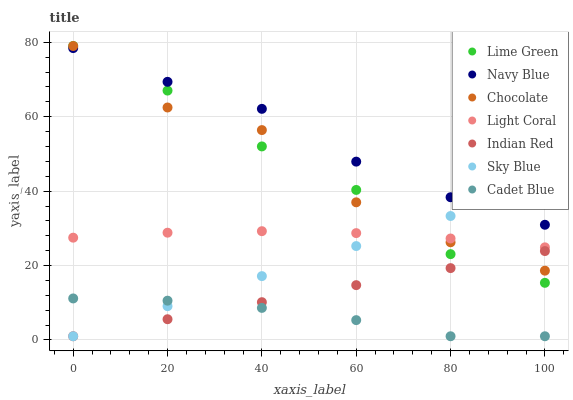Does Cadet Blue have the minimum area under the curve?
Answer yes or no. Yes. Does Navy Blue have the maximum area under the curve?
Answer yes or no. Yes. Does Chocolate have the minimum area under the curve?
Answer yes or no. No. Does Chocolate have the maximum area under the curve?
Answer yes or no. No. Is Sky Blue the smoothest?
Answer yes or no. Yes. Is Chocolate the roughest?
Answer yes or no. Yes. Is Navy Blue the smoothest?
Answer yes or no. No. Is Navy Blue the roughest?
Answer yes or no. No. Does Cadet Blue have the lowest value?
Answer yes or no. Yes. Does Chocolate have the lowest value?
Answer yes or no. No. Does Lime Green have the highest value?
Answer yes or no. Yes. Does Navy Blue have the highest value?
Answer yes or no. No. Is Cadet Blue less than Chocolate?
Answer yes or no. Yes. Is Chocolate greater than Cadet Blue?
Answer yes or no. Yes. Does Indian Red intersect Lime Green?
Answer yes or no. Yes. Is Indian Red less than Lime Green?
Answer yes or no. No. Is Indian Red greater than Lime Green?
Answer yes or no. No. Does Cadet Blue intersect Chocolate?
Answer yes or no. No. 